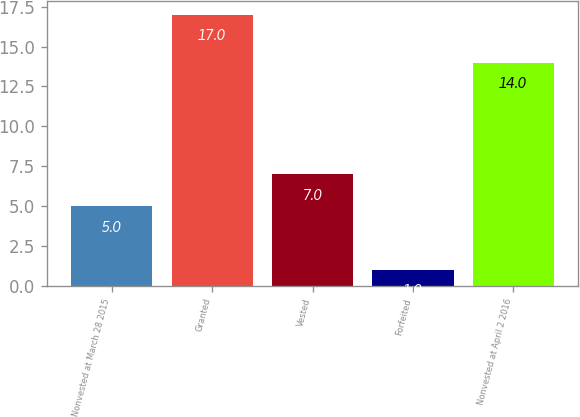Convert chart to OTSL. <chart><loc_0><loc_0><loc_500><loc_500><bar_chart><fcel>Nonvested at March 28 2015<fcel>Granted<fcel>Vested<fcel>Forfeited<fcel>Nonvested at April 2 2016<nl><fcel>5<fcel>17<fcel>7<fcel>1<fcel>14<nl></chart> 